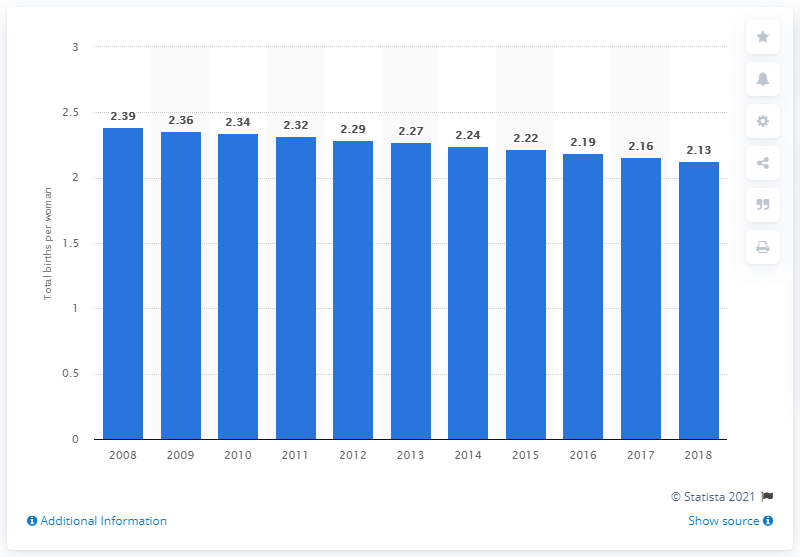List a handful of essential elements in this visual. The average fertility rate in Mexico in 2018 was 2.13 children per woman, according to data. 